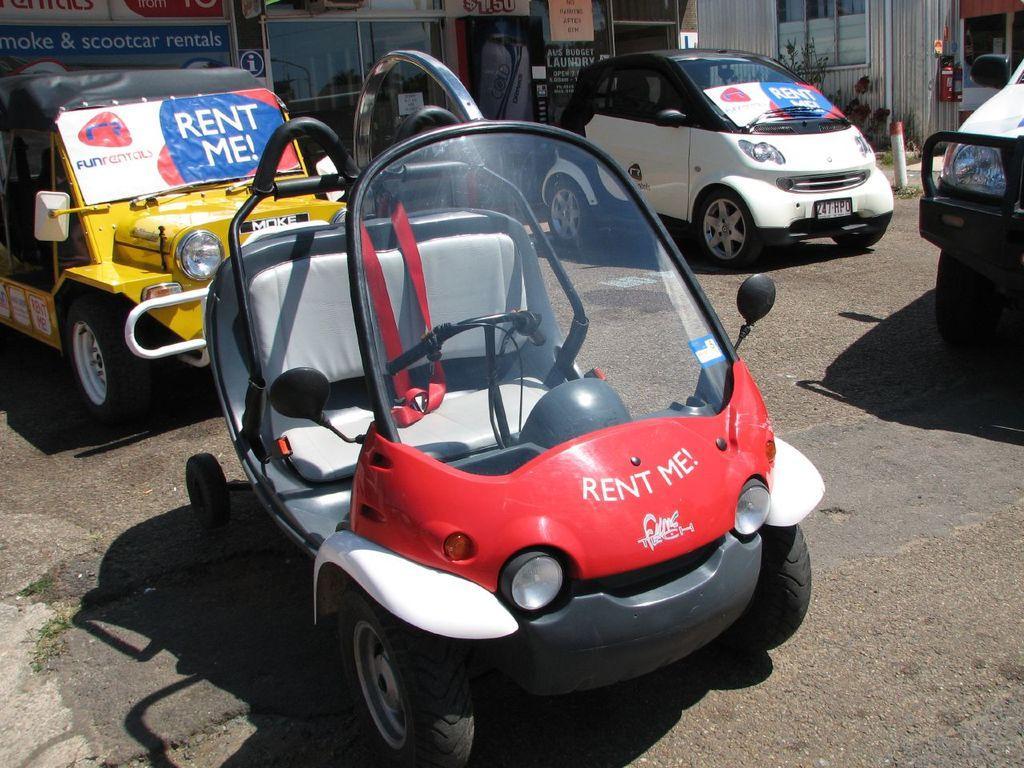Could you give a brief overview of what you see in this image? In the foreground I can see vehicles on the road, grass and poles. In the background I can see buildings, windows, boards and houseplants. This image is taken may be during a day. 